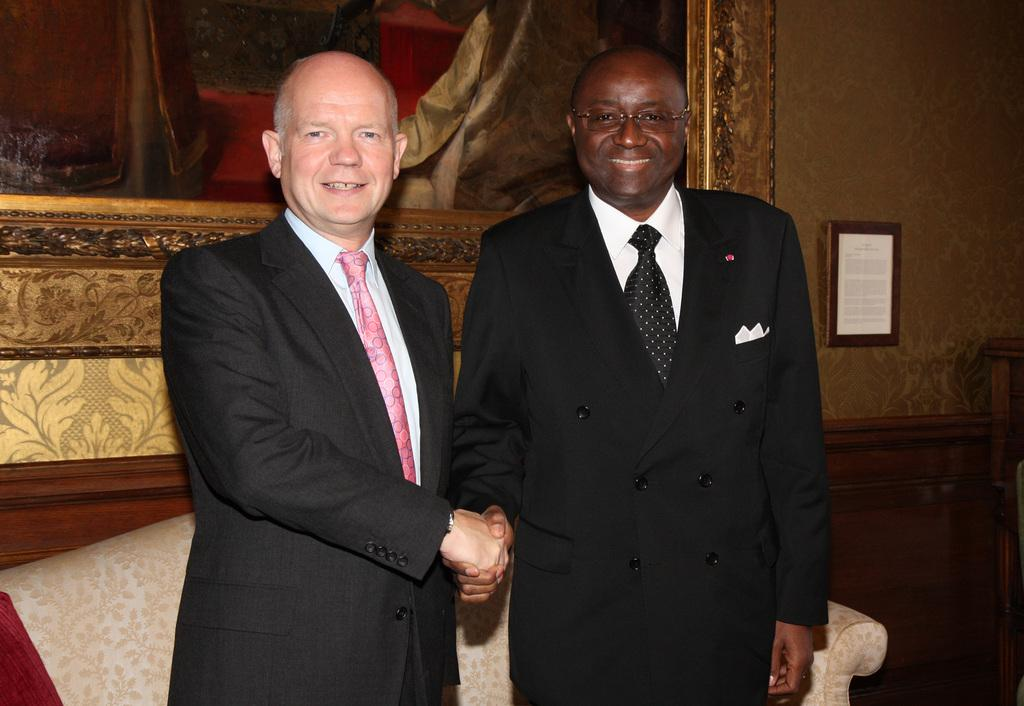How many people are present in the image? There are two people in the image. What type of furniture is visible in the image? There is a sofa in the image. Can you describe something on the wall in the background of the image? There is a photo frame on the wall in the background of the image. What type of gun is being used by one of the people in the image? There is no gun present in the image; it only features two people and a sofa. 